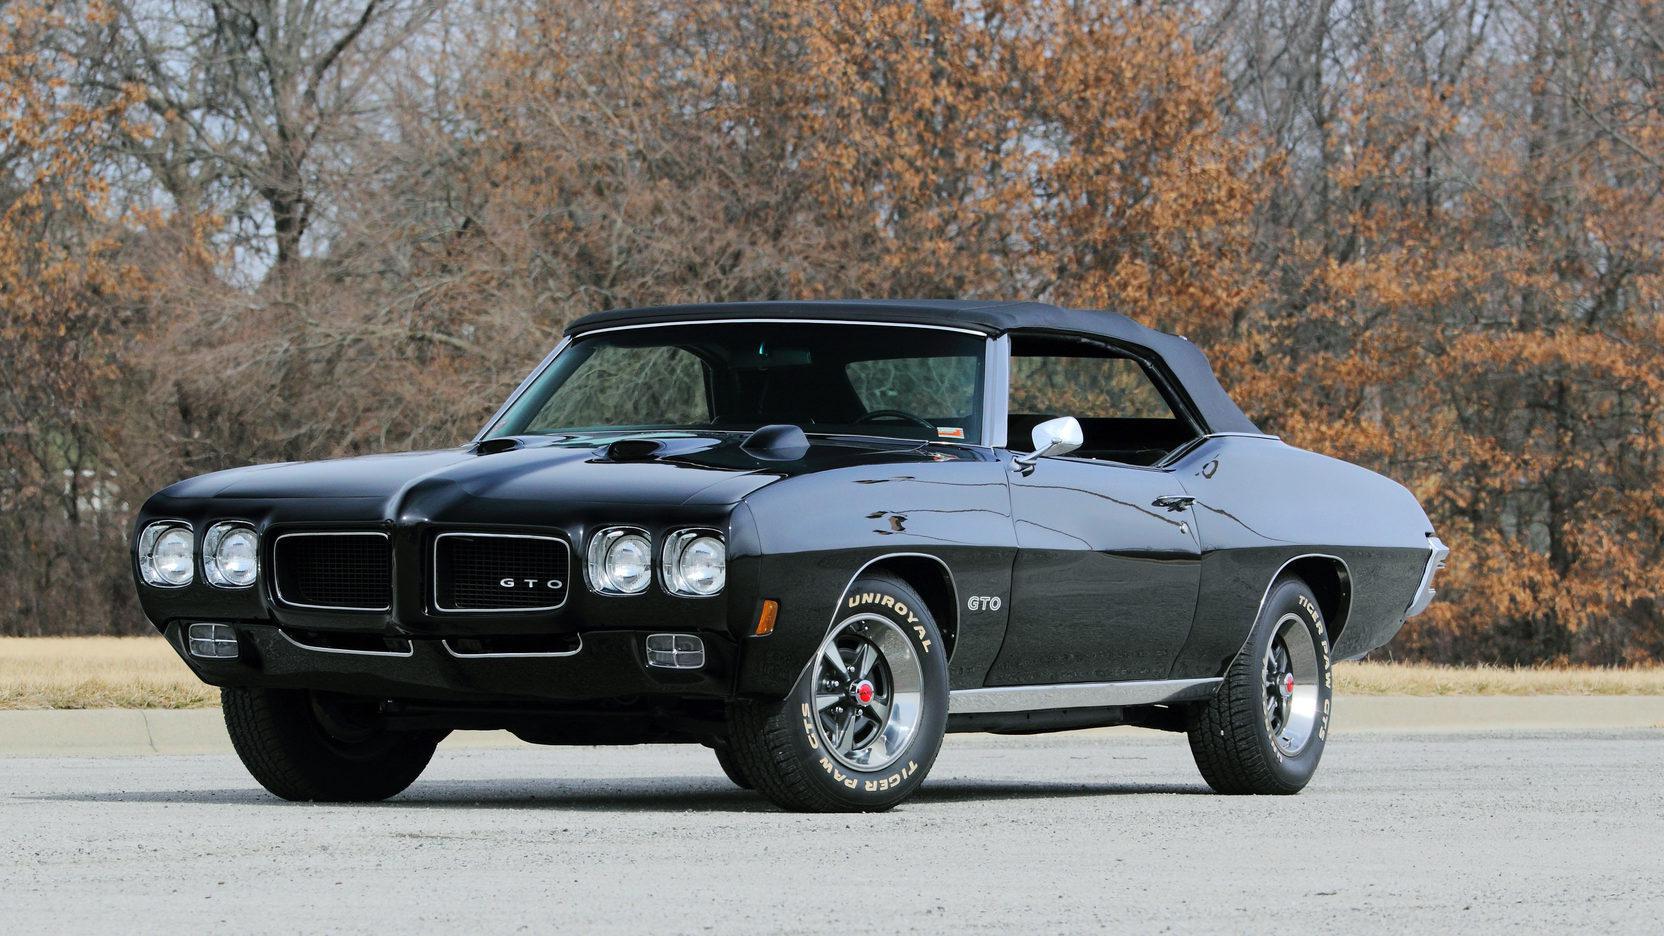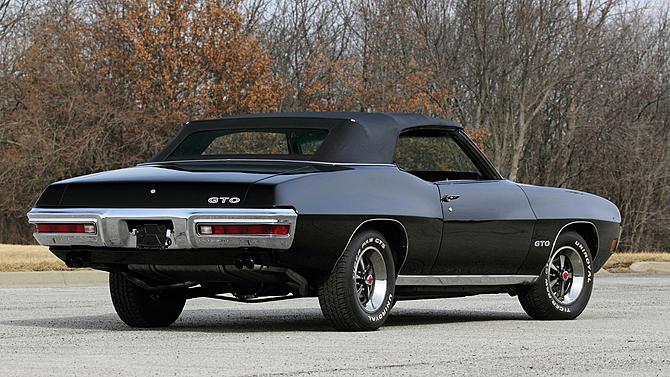The first image is the image on the left, the second image is the image on the right. Given the left and right images, does the statement "At least one car has its top down." hold true? Answer yes or no. No. 